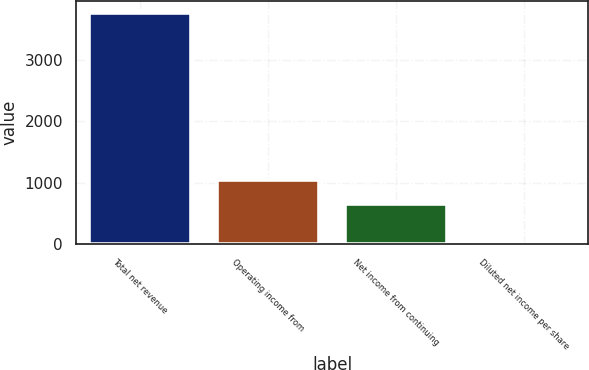Convert chart to OTSL. <chart><loc_0><loc_0><loc_500><loc_500><bar_chart><fcel>Total net revenue<fcel>Operating income from<fcel>Net income from continuing<fcel>Diluted net income per share<nl><fcel>3772<fcel>1037<fcel>652<fcel>2.06<nl></chart> 